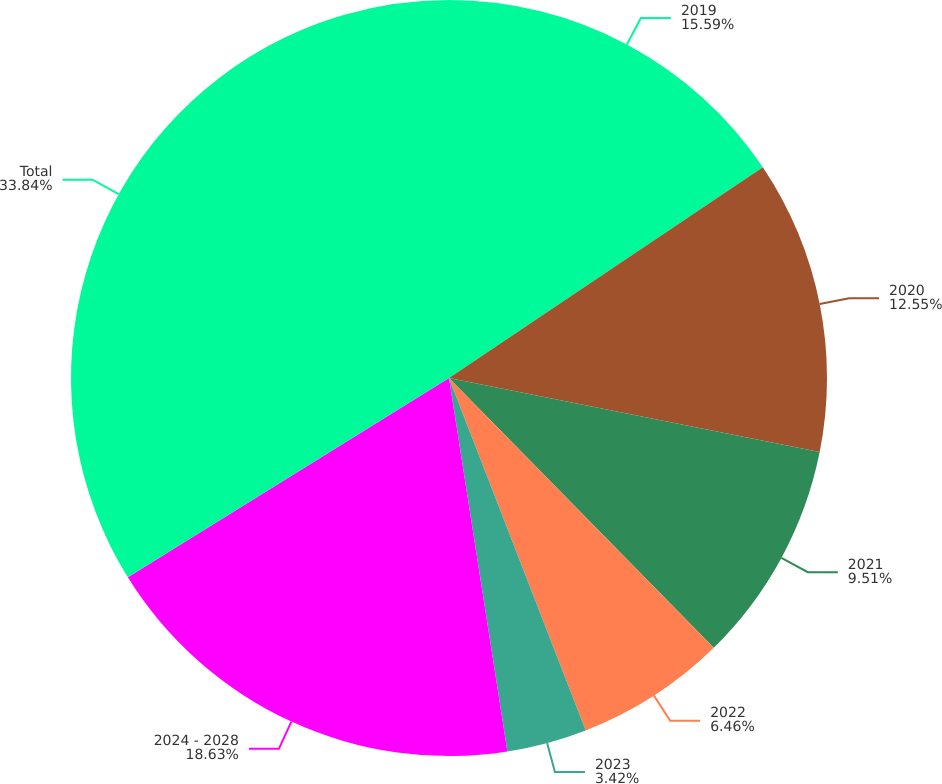Convert chart. <chart><loc_0><loc_0><loc_500><loc_500><pie_chart><fcel>2019<fcel>2020<fcel>2021<fcel>2022<fcel>2023<fcel>2024 - 2028<fcel>Total<nl><fcel>15.59%<fcel>12.55%<fcel>9.51%<fcel>6.46%<fcel>3.42%<fcel>18.63%<fcel>33.84%<nl></chart> 